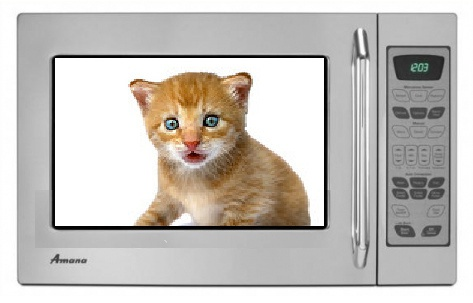Describe the objects in this image and their specific colors. I can see microwave in darkgray, white, gray, and black tones and cat in white, gray, tan, and olive tones in this image. 